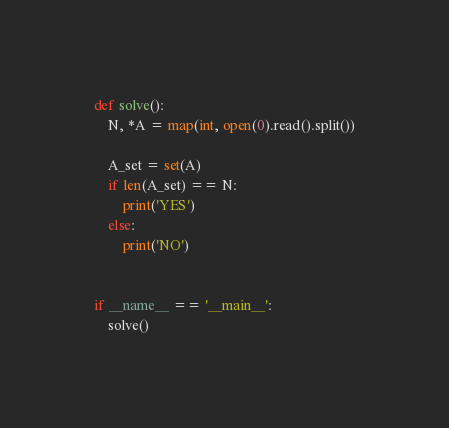<code> <loc_0><loc_0><loc_500><loc_500><_Python_>def solve():
    N, *A = map(int, open(0).read().split())
    
    A_set = set(A)
    if len(A_set) == N:
        print('YES')
    else:
        print('NO')


if __name__ == '__main__':
    solve()
</code> 